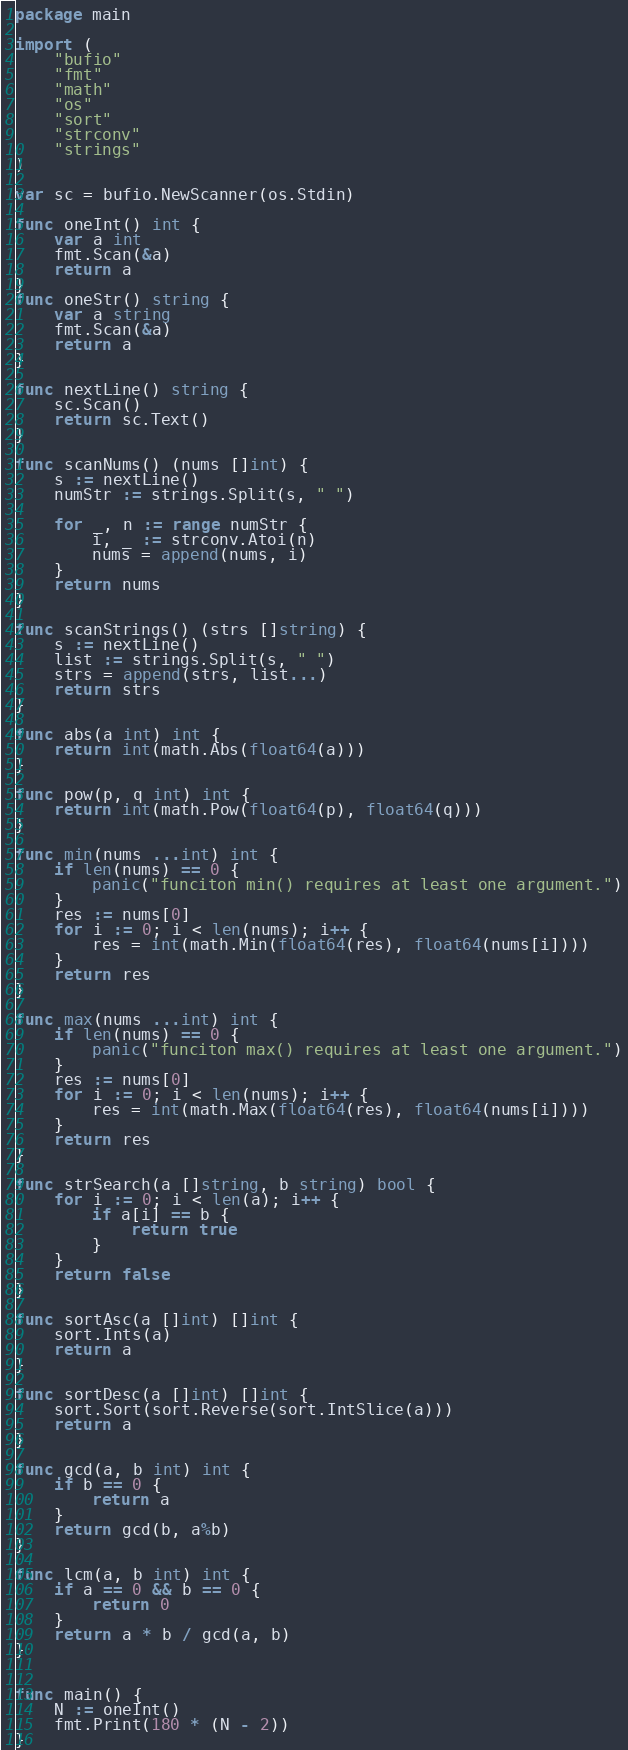<code> <loc_0><loc_0><loc_500><loc_500><_Go_>package main

import (
	"bufio"
	"fmt"
	"math"
	"os"
	"sort"
	"strconv"
	"strings"
)

var sc = bufio.NewScanner(os.Stdin)

func oneInt() int {
	var a int
	fmt.Scan(&a)
	return a
}
func oneStr() string {
	var a string
	fmt.Scan(&a)
	return a
}

func nextLine() string {
	sc.Scan()
	return sc.Text()
}

func scanNums() (nums []int) {
	s := nextLine()
	numStr := strings.Split(s, " ")

	for _, n := range numStr {
		i, _ := strconv.Atoi(n)
		nums = append(nums, i)
	}
	return nums
}

func scanStrings() (strs []string) {
	s := nextLine()
	list := strings.Split(s, " ")
	strs = append(strs, list...)
	return strs
}

func abs(a int) int {
	return int(math.Abs(float64(a)))
}

func pow(p, q int) int {
	return int(math.Pow(float64(p), float64(q)))
}

func min(nums ...int) int {
	if len(nums) == 0 {
		panic("funciton min() requires at least one argument.")
	}
	res := nums[0]
	for i := 0; i < len(nums); i++ {
		res = int(math.Min(float64(res), float64(nums[i])))
	}
	return res
}

func max(nums ...int) int {
	if len(nums) == 0 {
		panic("funciton max() requires at least one argument.")
	}
	res := nums[0]
	for i := 0; i < len(nums); i++ {
		res = int(math.Max(float64(res), float64(nums[i])))
	}
	return res
}

func strSearch(a []string, b string) bool {
	for i := 0; i < len(a); i++ {
		if a[i] == b {
			return true
		}
	}
	return false
}

func sortAsc(a []int) []int {
	sort.Ints(a)
	return a
}

func sortDesc(a []int) []int {
	sort.Sort(sort.Reverse(sort.IntSlice(a)))
	return a
}

func gcd(a, b int) int {
	if b == 0 {
		return a
	}
	return gcd(b, a%b)
}

func lcm(a, b int) int {
	if a == 0 && b == 0 {
		return 0
	}
	return a * b / gcd(a, b)
}


func main() {
	N := oneInt()
	fmt.Print(180 * (N - 2))
}
</code> 